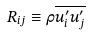<formula> <loc_0><loc_0><loc_500><loc_500>R _ { i j } \equiv \rho \overline { u _ { i } ^ { \prime } u _ { j } ^ { \prime } }</formula> 